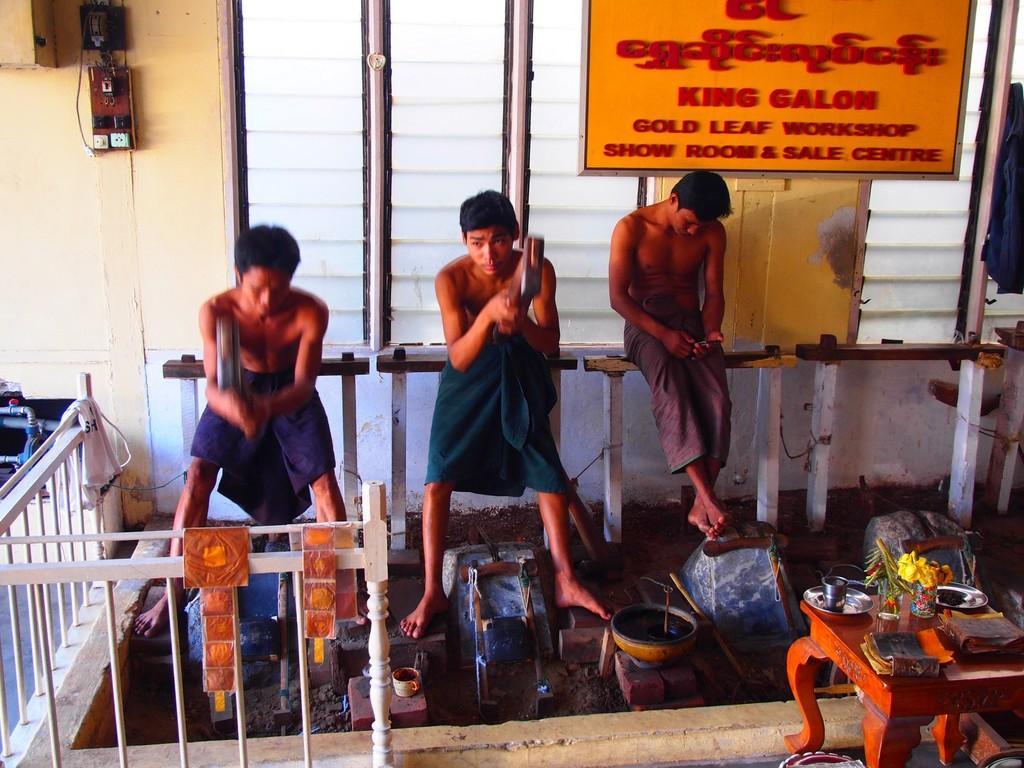Describe this image in one or two sentences. In this image there are 3 boys are standing on the floor and in front of them the table is there and on the table there are two books,plate and glasses are there and behind the boys one board,window and switch board is also there the background is cloudy. 